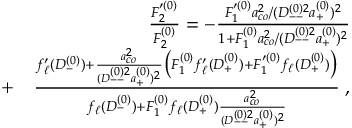<formula> <loc_0><loc_0><loc_500><loc_500>\begin{array} { r l r } & { \frac { F _ { 2 } ^ { \prime ( 0 ) } } { F _ { 2 } ^ { ( 0 ) } } = - \frac { F _ { 1 } ^ { \prime ( 0 ) } a _ { c o } ^ { 2 } / ( D _ { - - } ^ { ( 0 ) 2 } a _ { + } ^ { ( 0 ) } ) ^ { 2 } } { 1 + F _ { 1 } ^ { ( 0 ) } a _ { c o } ^ { 2 } / ( D _ { - - } ^ { ( 0 ) 2 } a _ { + } ^ { ( 0 ) } ) ^ { 2 } } } \\ & { + } & { \frac { f _ { \ell } ^ { \prime } ( D _ { - } ^ { ( 0 ) } ) + \frac { a _ { c o } ^ { 2 } } { ( D _ { - - } ^ { ( 0 ) 2 } a _ { + } ^ { ( 0 ) } ) ^ { 2 } } \left ( F _ { 1 } ^ { ( 0 ) } f _ { \ell } ^ { \prime } ( D _ { + } ^ { ( 0 ) } ) + F _ { 1 } ^ { \prime ( 0 ) } f _ { \ell } ( D _ { + } ^ { ( 0 ) } ) \right ) } { f _ { \ell } ( D _ { - } ^ { ( 0 ) } ) + F _ { 1 } ^ { ( 0 ) } f _ { \ell } ( D _ { + } ^ { ( 0 ) } ) \frac { a _ { c o } ^ { 2 } } { ( D _ { - - } ^ { ( 0 ) 2 } a _ { + } ^ { ( 0 ) } ) ^ { 2 } } } \, , } \end{array}</formula> 